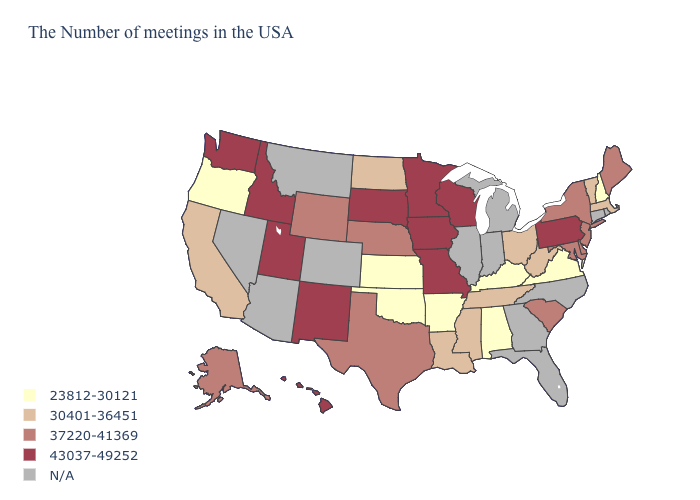Among the states that border North Carolina , does South Carolina have the lowest value?
Give a very brief answer. No. What is the value of Ohio?
Short answer required. 30401-36451. Does California have the lowest value in the West?
Keep it brief. No. Which states hav the highest value in the South?
Concise answer only. Delaware, Maryland, South Carolina, Texas. What is the lowest value in the MidWest?
Answer briefly. 23812-30121. Name the states that have a value in the range 37220-41369?
Answer briefly. Maine, New York, New Jersey, Delaware, Maryland, South Carolina, Nebraska, Texas, Wyoming, Alaska. Which states have the lowest value in the USA?
Quick response, please. New Hampshire, Virginia, Kentucky, Alabama, Arkansas, Kansas, Oklahoma, Oregon. What is the value of Vermont?
Short answer required. 30401-36451. Among the states that border Ohio , which have the highest value?
Write a very short answer. Pennsylvania. Name the states that have a value in the range N/A?
Concise answer only. Rhode Island, Connecticut, North Carolina, Florida, Georgia, Michigan, Indiana, Illinois, Colorado, Montana, Arizona, Nevada. Among the states that border Georgia , does Tennessee have the highest value?
Write a very short answer. No. What is the value of Arizona?
Be succinct. N/A. What is the lowest value in states that border Vermont?
Answer briefly. 23812-30121. What is the highest value in the USA?
Quick response, please. 43037-49252. Does Oregon have the lowest value in the West?
Keep it brief. Yes. 